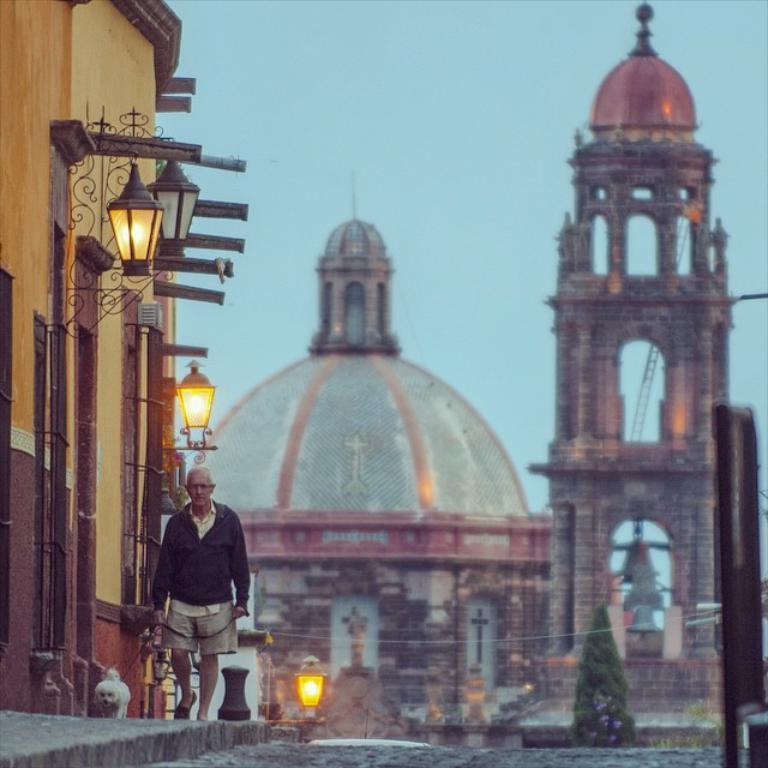Please provide a concise description of this image. In this image in the center there is one man who is holding a dog and walking on a footpath. At the bottom there is a road and on the left side there is a building and two lights, in the background there are some buildings and trees. 